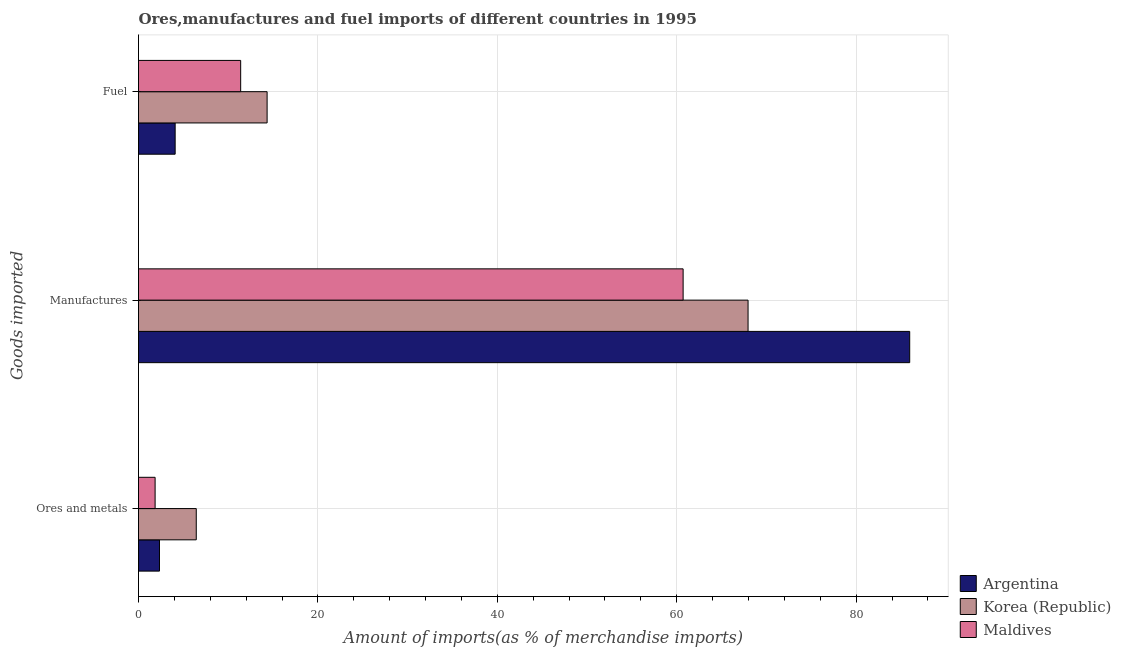How many groups of bars are there?
Offer a terse response. 3. Are the number of bars per tick equal to the number of legend labels?
Your response must be concise. Yes. Are the number of bars on each tick of the Y-axis equal?
Offer a very short reply. Yes. What is the label of the 1st group of bars from the top?
Provide a short and direct response. Fuel. What is the percentage of manufactures imports in Korea (Republic)?
Ensure brevity in your answer.  67.95. Across all countries, what is the maximum percentage of fuel imports?
Make the answer very short. 14.34. Across all countries, what is the minimum percentage of manufactures imports?
Give a very brief answer. 60.71. In which country was the percentage of manufactures imports minimum?
Provide a succinct answer. Maldives. What is the total percentage of manufactures imports in the graph?
Offer a terse response. 214.63. What is the difference between the percentage of ores and metals imports in Maldives and that in Argentina?
Make the answer very short. -0.49. What is the difference between the percentage of ores and metals imports in Korea (Republic) and the percentage of manufactures imports in Maldives?
Your response must be concise. -54.27. What is the average percentage of ores and metals imports per country?
Offer a very short reply. 3.54. What is the difference between the percentage of manufactures imports and percentage of fuel imports in Maldives?
Your answer should be very brief. 49.32. What is the ratio of the percentage of fuel imports in Maldives to that in Korea (Republic)?
Provide a short and direct response. 0.79. Is the percentage of ores and metals imports in Argentina less than that in Maldives?
Your answer should be compact. No. Is the difference between the percentage of manufactures imports in Maldives and Korea (Republic) greater than the difference between the percentage of ores and metals imports in Maldives and Korea (Republic)?
Offer a very short reply. No. What is the difference between the highest and the second highest percentage of manufactures imports?
Give a very brief answer. 18.02. What is the difference between the highest and the lowest percentage of fuel imports?
Your response must be concise. 10.25. In how many countries, is the percentage of ores and metals imports greater than the average percentage of ores and metals imports taken over all countries?
Keep it short and to the point. 1. What does the 1st bar from the top in Ores and metals represents?
Offer a very short reply. Maldives. Is it the case that in every country, the sum of the percentage of ores and metals imports and percentage of manufactures imports is greater than the percentage of fuel imports?
Make the answer very short. Yes. Are all the bars in the graph horizontal?
Provide a succinct answer. Yes. How many countries are there in the graph?
Keep it short and to the point. 3. Where does the legend appear in the graph?
Keep it short and to the point. Bottom right. How many legend labels are there?
Offer a very short reply. 3. What is the title of the graph?
Offer a terse response. Ores,manufactures and fuel imports of different countries in 1995. Does "Dominica" appear as one of the legend labels in the graph?
Your answer should be very brief. No. What is the label or title of the X-axis?
Your answer should be compact. Amount of imports(as % of merchandise imports). What is the label or title of the Y-axis?
Your answer should be very brief. Goods imported. What is the Amount of imports(as % of merchandise imports) of Argentina in Ores and metals?
Provide a short and direct response. 2.34. What is the Amount of imports(as % of merchandise imports) of Korea (Republic) in Ores and metals?
Your answer should be very brief. 6.44. What is the Amount of imports(as % of merchandise imports) of Maldives in Ores and metals?
Give a very brief answer. 1.85. What is the Amount of imports(as % of merchandise imports) in Argentina in Manufactures?
Your answer should be very brief. 85.97. What is the Amount of imports(as % of merchandise imports) in Korea (Republic) in Manufactures?
Offer a terse response. 67.95. What is the Amount of imports(as % of merchandise imports) of Maldives in Manufactures?
Keep it short and to the point. 60.71. What is the Amount of imports(as % of merchandise imports) in Argentina in Fuel?
Make the answer very short. 4.08. What is the Amount of imports(as % of merchandise imports) of Korea (Republic) in Fuel?
Your answer should be compact. 14.34. What is the Amount of imports(as % of merchandise imports) of Maldives in Fuel?
Offer a terse response. 11.39. Across all Goods imported, what is the maximum Amount of imports(as % of merchandise imports) of Argentina?
Ensure brevity in your answer.  85.97. Across all Goods imported, what is the maximum Amount of imports(as % of merchandise imports) of Korea (Republic)?
Your response must be concise. 67.95. Across all Goods imported, what is the maximum Amount of imports(as % of merchandise imports) of Maldives?
Ensure brevity in your answer.  60.71. Across all Goods imported, what is the minimum Amount of imports(as % of merchandise imports) in Argentina?
Provide a short and direct response. 2.34. Across all Goods imported, what is the minimum Amount of imports(as % of merchandise imports) in Korea (Republic)?
Offer a terse response. 6.44. Across all Goods imported, what is the minimum Amount of imports(as % of merchandise imports) of Maldives?
Make the answer very short. 1.85. What is the total Amount of imports(as % of merchandise imports) in Argentina in the graph?
Your response must be concise. 92.39. What is the total Amount of imports(as % of merchandise imports) in Korea (Republic) in the graph?
Your answer should be compact. 88.72. What is the total Amount of imports(as % of merchandise imports) in Maldives in the graph?
Offer a terse response. 73.95. What is the difference between the Amount of imports(as % of merchandise imports) of Argentina in Ores and metals and that in Manufactures?
Offer a terse response. -83.63. What is the difference between the Amount of imports(as % of merchandise imports) in Korea (Republic) in Ores and metals and that in Manufactures?
Give a very brief answer. -61.51. What is the difference between the Amount of imports(as % of merchandise imports) in Maldives in Ores and metals and that in Manufactures?
Your answer should be very brief. -58.86. What is the difference between the Amount of imports(as % of merchandise imports) in Argentina in Ores and metals and that in Fuel?
Provide a succinct answer. -1.75. What is the difference between the Amount of imports(as % of merchandise imports) in Korea (Republic) in Ores and metals and that in Fuel?
Provide a succinct answer. -7.9. What is the difference between the Amount of imports(as % of merchandise imports) of Maldives in Ores and metals and that in Fuel?
Your response must be concise. -9.54. What is the difference between the Amount of imports(as % of merchandise imports) in Argentina in Manufactures and that in Fuel?
Offer a very short reply. 81.88. What is the difference between the Amount of imports(as % of merchandise imports) in Korea (Republic) in Manufactures and that in Fuel?
Your answer should be compact. 53.62. What is the difference between the Amount of imports(as % of merchandise imports) of Maldives in Manufactures and that in Fuel?
Offer a very short reply. 49.32. What is the difference between the Amount of imports(as % of merchandise imports) in Argentina in Ores and metals and the Amount of imports(as % of merchandise imports) in Korea (Republic) in Manufactures?
Your answer should be compact. -65.61. What is the difference between the Amount of imports(as % of merchandise imports) in Argentina in Ores and metals and the Amount of imports(as % of merchandise imports) in Maldives in Manufactures?
Provide a succinct answer. -58.37. What is the difference between the Amount of imports(as % of merchandise imports) of Korea (Republic) in Ores and metals and the Amount of imports(as % of merchandise imports) of Maldives in Manufactures?
Your response must be concise. -54.27. What is the difference between the Amount of imports(as % of merchandise imports) of Argentina in Ores and metals and the Amount of imports(as % of merchandise imports) of Korea (Republic) in Fuel?
Your response must be concise. -12. What is the difference between the Amount of imports(as % of merchandise imports) of Argentina in Ores and metals and the Amount of imports(as % of merchandise imports) of Maldives in Fuel?
Offer a very short reply. -9.05. What is the difference between the Amount of imports(as % of merchandise imports) in Korea (Republic) in Ores and metals and the Amount of imports(as % of merchandise imports) in Maldives in Fuel?
Your answer should be very brief. -4.95. What is the difference between the Amount of imports(as % of merchandise imports) of Argentina in Manufactures and the Amount of imports(as % of merchandise imports) of Korea (Republic) in Fuel?
Your answer should be compact. 71.63. What is the difference between the Amount of imports(as % of merchandise imports) of Argentina in Manufactures and the Amount of imports(as % of merchandise imports) of Maldives in Fuel?
Ensure brevity in your answer.  74.58. What is the difference between the Amount of imports(as % of merchandise imports) of Korea (Republic) in Manufactures and the Amount of imports(as % of merchandise imports) of Maldives in Fuel?
Give a very brief answer. 56.56. What is the average Amount of imports(as % of merchandise imports) of Argentina per Goods imported?
Provide a short and direct response. 30.8. What is the average Amount of imports(as % of merchandise imports) in Korea (Republic) per Goods imported?
Your response must be concise. 29.57. What is the average Amount of imports(as % of merchandise imports) in Maldives per Goods imported?
Keep it short and to the point. 24.65. What is the difference between the Amount of imports(as % of merchandise imports) of Argentina and Amount of imports(as % of merchandise imports) of Korea (Republic) in Ores and metals?
Ensure brevity in your answer.  -4.1. What is the difference between the Amount of imports(as % of merchandise imports) of Argentina and Amount of imports(as % of merchandise imports) of Maldives in Ores and metals?
Offer a terse response. 0.49. What is the difference between the Amount of imports(as % of merchandise imports) in Korea (Republic) and Amount of imports(as % of merchandise imports) in Maldives in Ores and metals?
Your response must be concise. 4.59. What is the difference between the Amount of imports(as % of merchandise imports) of Argentina and Amount of imports(as % of merchandise imports) of Korea (Republic) in Manufactures?
Offer a terse response. 18.02. What is the difference between the Amount of imports(as % of merchandise imports) of Argentina and Amount of imports(as % of merchandise imports) of Maldives in Manufactures?
Ensure brevity in your answer.  25.26. What is the difference between the Amount of imports(as % of merchandise imports) in Korea (Republic) and Amount of imports(as % of merchandise imports) in Maldives in Manufactures?
Make the answer very short. 7.24. What is the difference between the Amount of imports(as % of merchandise imports) in Argentina and Amount of imports(as % of merchandise imports) in Korea (Republic) in Fuel?
Keep it short and to the point. -10.25. What is the difference between the Amount of imports(as % of merchandise imports) of Argentina and Amount of imports(as % of merchandise imports) of Maldives in Fuel?
Your response must be concise. -7.3. What is the difference between the Amount of imports(as % of merchandise imports) in Korea (Republic) and Amount of imports(as % of merchandise imports) in Maldives in Fuel?
Provide a short and direct response. 2.95. What is the ratio of the Amount of imports(as % of merchandise imports) in Argentina in Ores and metals to that in Manufactures?
Provide a succinct answer. 0.03. What is the ratio of the Amount of imports(as % of merchandise imports) in Korea (Republic) in Ores and metals to that in Manufactures?
Keep it short and to the point. 0.09. What is the ratio of the Amount of imports(as % of merchandise imports) in Maldives in Ores and metals to that in Manufactures?
Make the answer very short. 0.03. What is the ratio of the Amount of imports(as % of merchandise imports) of Argentina in Ores and metals to that in Fuel?
Give a very brief answer. 0.57. What is the ratio of the Amount of imports(as % of merchandise imports) of Korea (Republic) in Ores and metals to that in Fuel?
Your response must be concise. 0.45. What is the ratio of the Amount of imports(as % of merchandise imports) of Maldives in Ores and metals to that in Fuel?
Give a very brief answer. 0.16. What is the ratio of the Amount of imports(as % of merchandise imports) of Argentina in Manufactures to that in Fuel?
Give a very brief answer. 21.05. What is the ratio of the Amount of imports(as % of merchandise imports) in Korea (Republic) in Manufactures to that in Fuel?
Provide a succinct answer. 4.74. What is the ratio of the Amount of imports(as % of merchandise imports) of Maldives in Manufactures to that in Fuel?
Offer a terse response. 5.33. What is the difference between the highest and the second highest Amount of imports(as % of merchandise imports) in Argentina?
Give a very brief answer. 81.88. What is the difference between the highest and the second highest Amount of imports(as % of merchandise imports) of Korea (Republic)?
Your response must be concise. 53.62. What is the difference between the highest and the second highest Amount of imports(as % of merchandise imports) in Maldives?
Offer a very short reply. 49.32. What is the difference between the highest and the lowest Amount of imports(as % of merchandise imports) of Argentina?
Give a very brief answer. 83.63. What is the difference between the highest and the lowest Amount of imports(as % of merchandise imports) of Korea (Republic)?
Ensure brevity in your answer.  61.51. What is the difference between the highest and the lowest Amount of imports(as % of merchandise imports) in Maldives?
Your response must be concise. 58.86. 